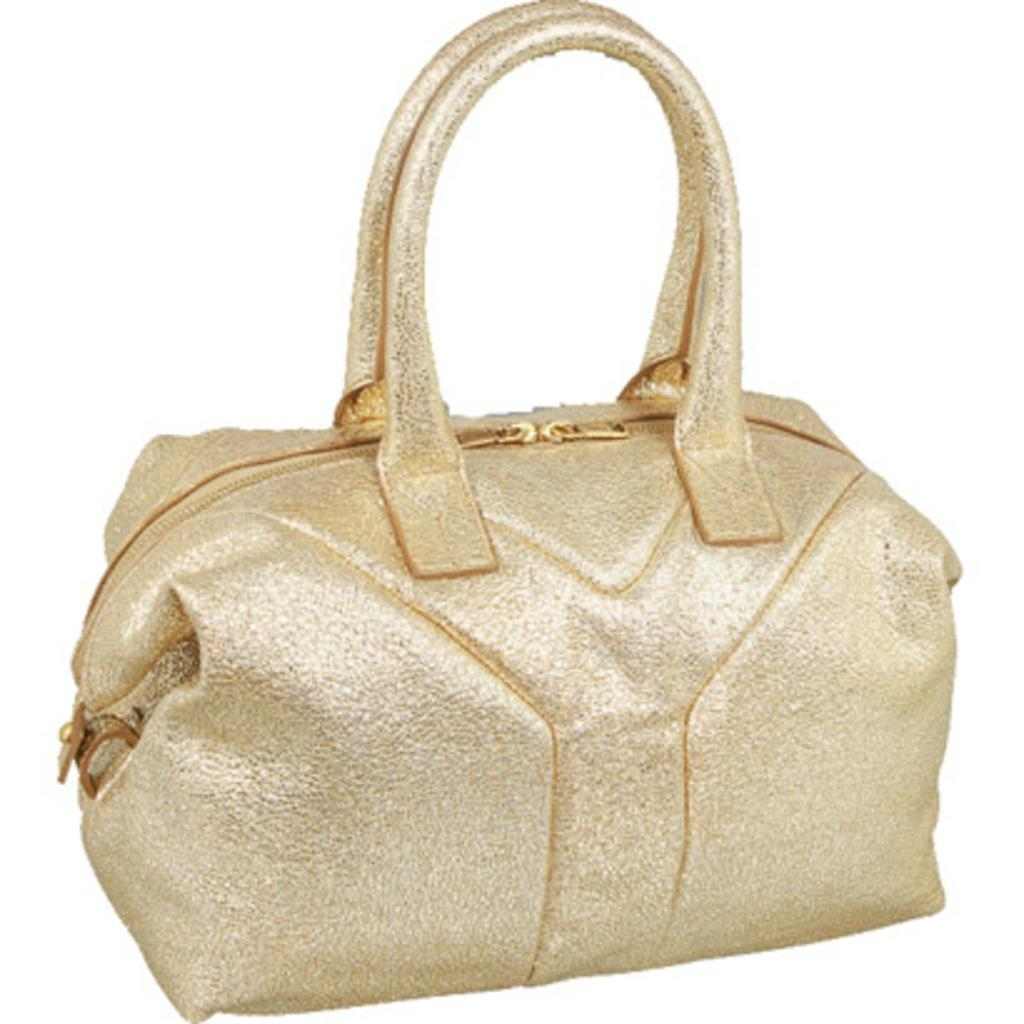What object can be seen in the image? There is a purse in the image. What is the color of the purse? The purse is gold in color. What color is the background of the purse? The background of the purse is white. How many ants can be seen crawling on the purse in the image? There are no ants present in the image; it only features a gold purse with a white background. 